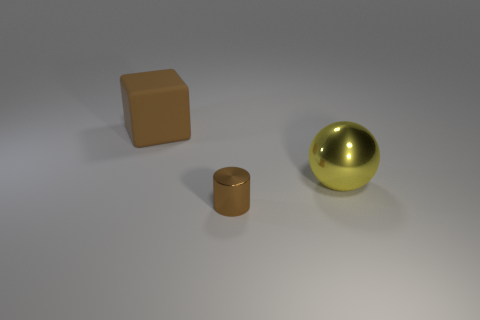Is there any other thing that has the same shape as the small brown shiny thing?
Offer a very short reply. No. Are there any other things that have the same size as the yellow object?
Ensure brevity in your answer.  Yes. There is a ball that is made of the same material as the tiny thing; what is its color?
Provide a short and direct response. Yellow. The big thing to the right of the brown rubber object is what color?
Offer a terse response. Yellow. How many blocks are the same color as the tiny cylinder?
Make the answer very short. 1. Is the number of big yellow shiny things that are in front of the yellow metal thing less than the number of large balls that are in front of the tiny object?
Your answer should be very brief. No. How many brown shiny things are to the left of the large yellow ball?
Make the answer very short. 1. Are there any small cyan objects that have the same material as the sphere?
Your response must be concise. No. Is the number of large yellow metallic things that are behind the matte block greater than the number of rubber blocks on the right side of the ball?
Offer a terse response. No. What size is the yellow ball?
Offer a terse response. Large. 